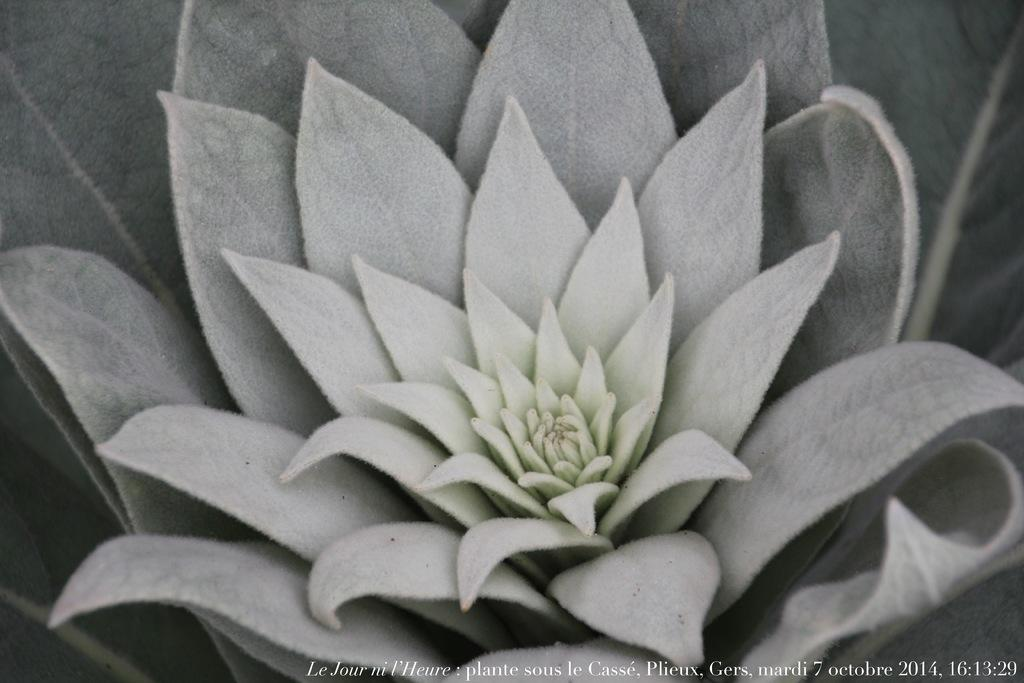What is the main subject of the image? The main subject of the image is a flower. How is the flower depicted in the image? The flower is truncated in the image. What else can be seen in the image besides the flower? There are leaves in the image. How are the leaves depicted in the image? The leaves are truncated in the image. What is written or displayed at the bottom of the image? There is text at the bottom of the image. Can you see a rifle leaning against the wall in the image? There is no rifle or wall present in the image; it features a truncated flower and leaves with text at the bottom. 